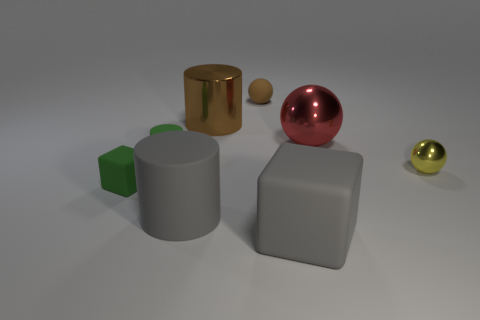Subtract all large cylinders. How many cylinders are left? 1 Add 1 brown cylinders. How many objects exist? 9 Subtract 1 spheres. How many spheres are left? 2 Subtract all balls. How many objects are left? 5 Subtract all green cylinders. How many cylinders are left? 2 Subtract all red blocks. Subtract all green cylinders. How many blocks are left? 2 Add 1 tiny spheres. How many tiny spheres are left? 3 Add 2 green objects. How many green objects exist? 4 Subtract 0 red cylinders. How many objects are left? 8 Subtract all brown cylinders. How many purple blocks are left? 0 